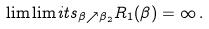Convert formula to latex. <formula><loc_0><loc_0><loc_500><loc_500>\lim \lim i t s _ { \beta \nearrow \beta _ { 2 } } R _ { 1 } ( \beta ) = \infty \, .</formula> 